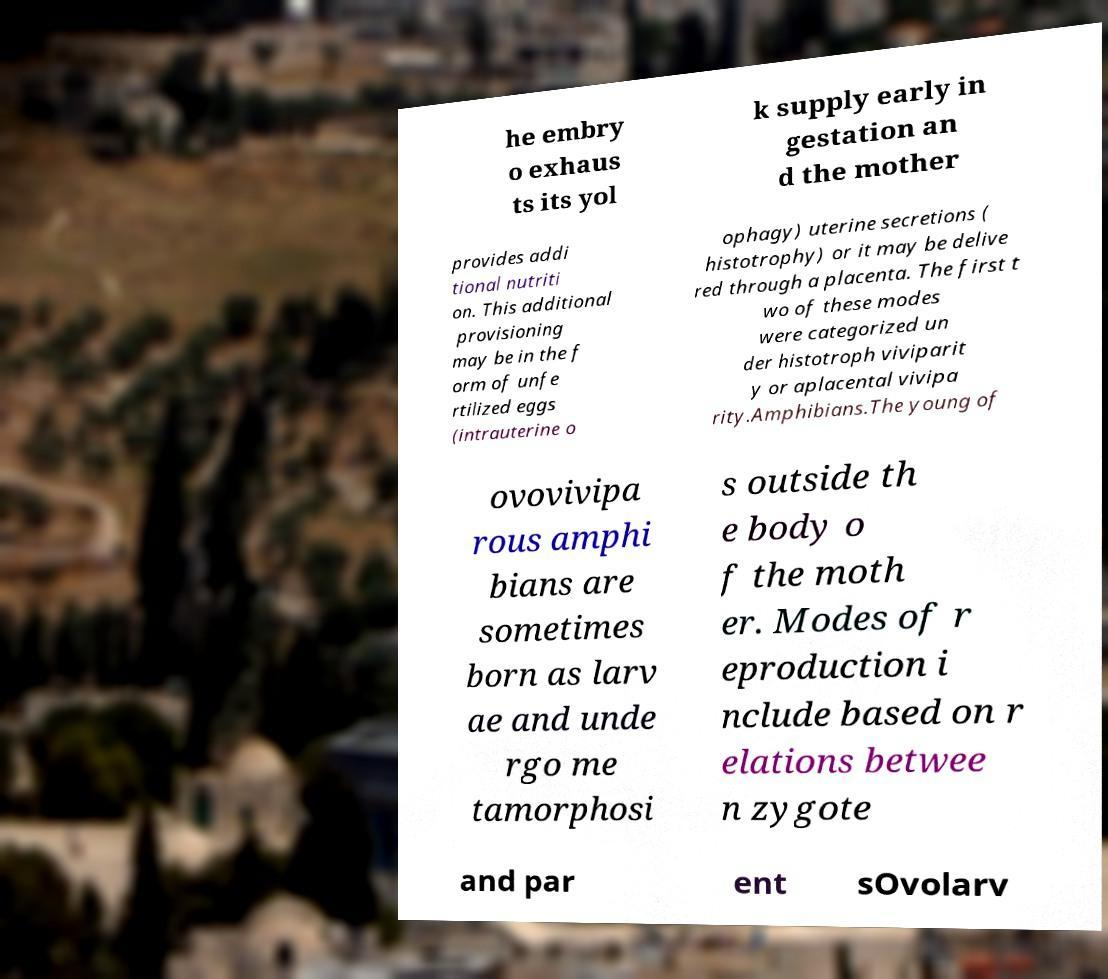What messages or text are displayed in this image? I need them in a readable, typed format. he embry o exhaus ts its yol k supply early in gestation an d the mother provides addi tional nutriti on. This additional provisioning may be in the f orm of unfe rtilized eggs (intrauterine o ophagy) uterine secretions ( histotrophy) or it may be delive red through a placenta. The first t wo of these modes were categorized un der histotroph viviparit y or aplacental vivipa rity.Amphibians.The young of ovovivipa rous amphi bians are sometimes born as larv ae and unde rgo me tamorphosi s outside th e body o f the moth er. Modes of r eproduction i nclude based on r elations betwee n zygote and par ent sOvolarv 